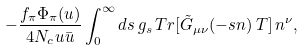<formula> <loc_0><loc_0><loc_500><loc_500>- \frac { f _ { \pi } \Phi _ { \pi } ( u ) } { 4 N _ { c } u \bar { u } } \int ^ { \infty } _ { 0 } d s \, g _ { s } \, T r [ \tilde { G } _ { \mu \nu } ( - s n ) \, T ] \, n ^ { \nu } ,</formula> 